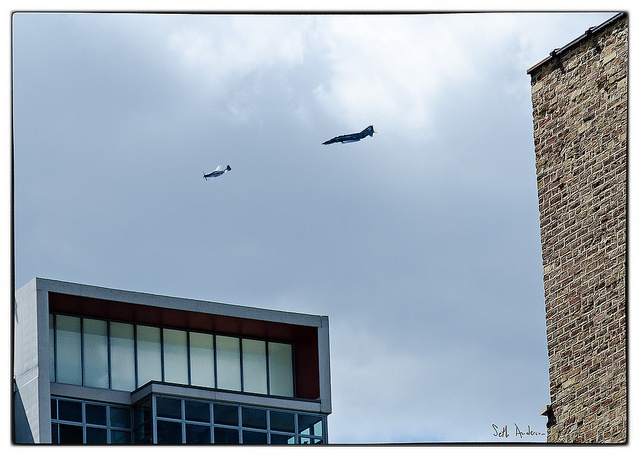Describe the objects in this image and their specific colors. I can see airplane in white, black, navy, and blue tones and airplane in white, black, blue, gray, and navy tones in this image. 